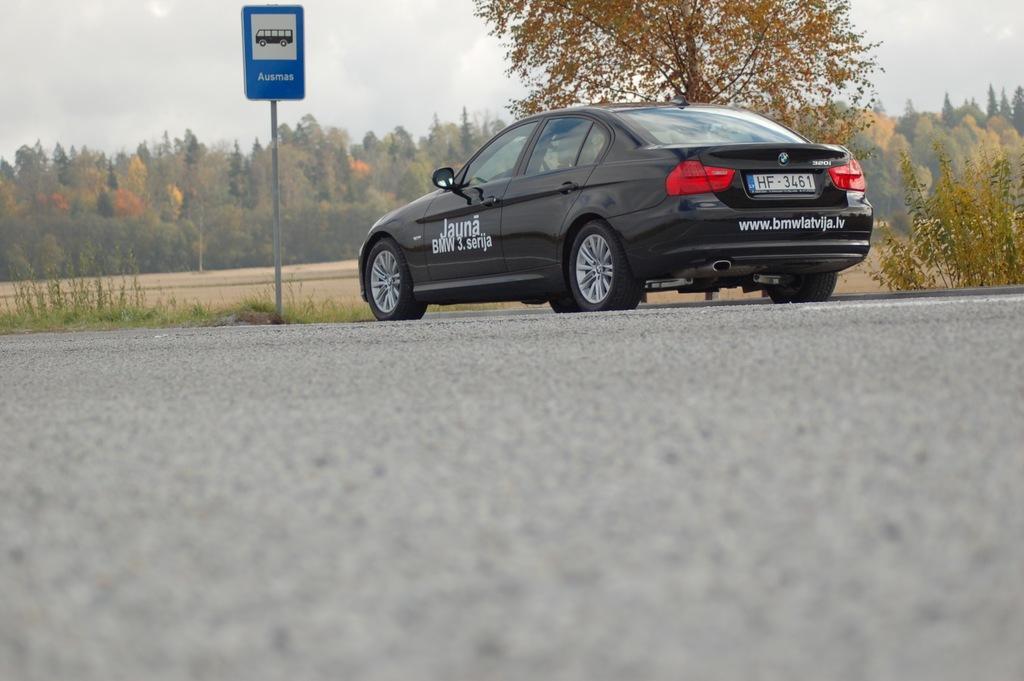In one or two sentences, can you explain what this image depicts? In this image we can see a car. In the back there is a sign board with a pole. In the background there are trees and sky. Also there are plants. 